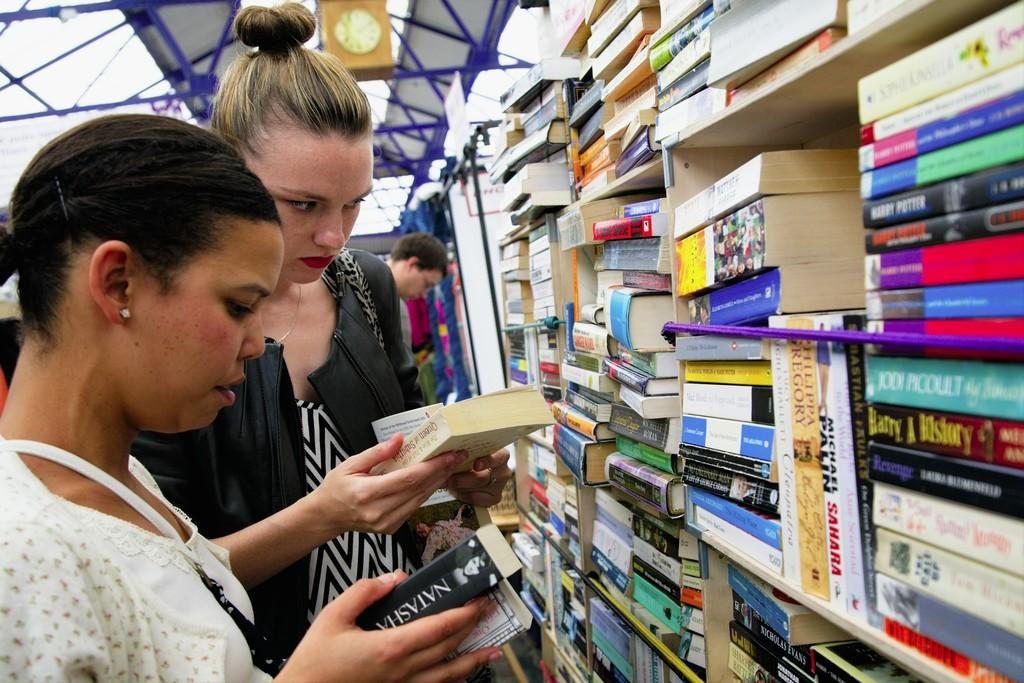<image>
Render a clear and concise summary of the photo. A woman looks at a book with the name Natasha on the spine, while her friend looks at a different book. 